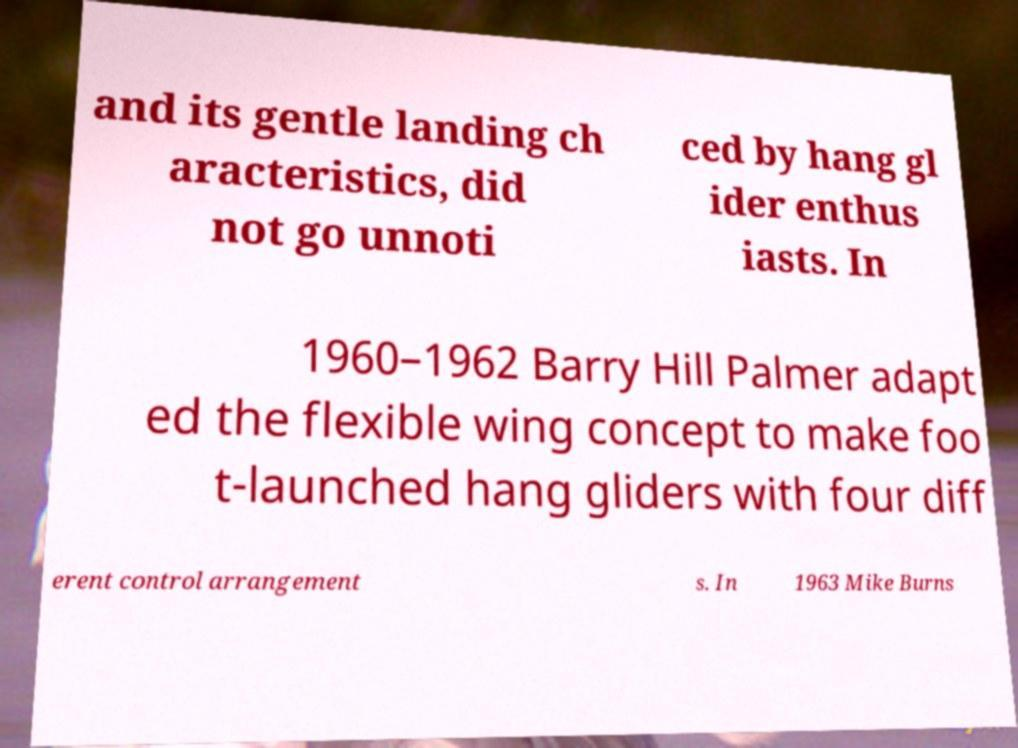For documentation purposes, I need the text within this image transcribed. Could you provide that? and its gentle landing ch aracteristics, did not go unnoti ced by hang gl ider enthus iasts. In 1960–1962 Barry Hill Palmer adapt ed the flexible wing concept to make foo t-launched hang gliders with four diff erent control arrangement s. In 1963 Mike Burns 